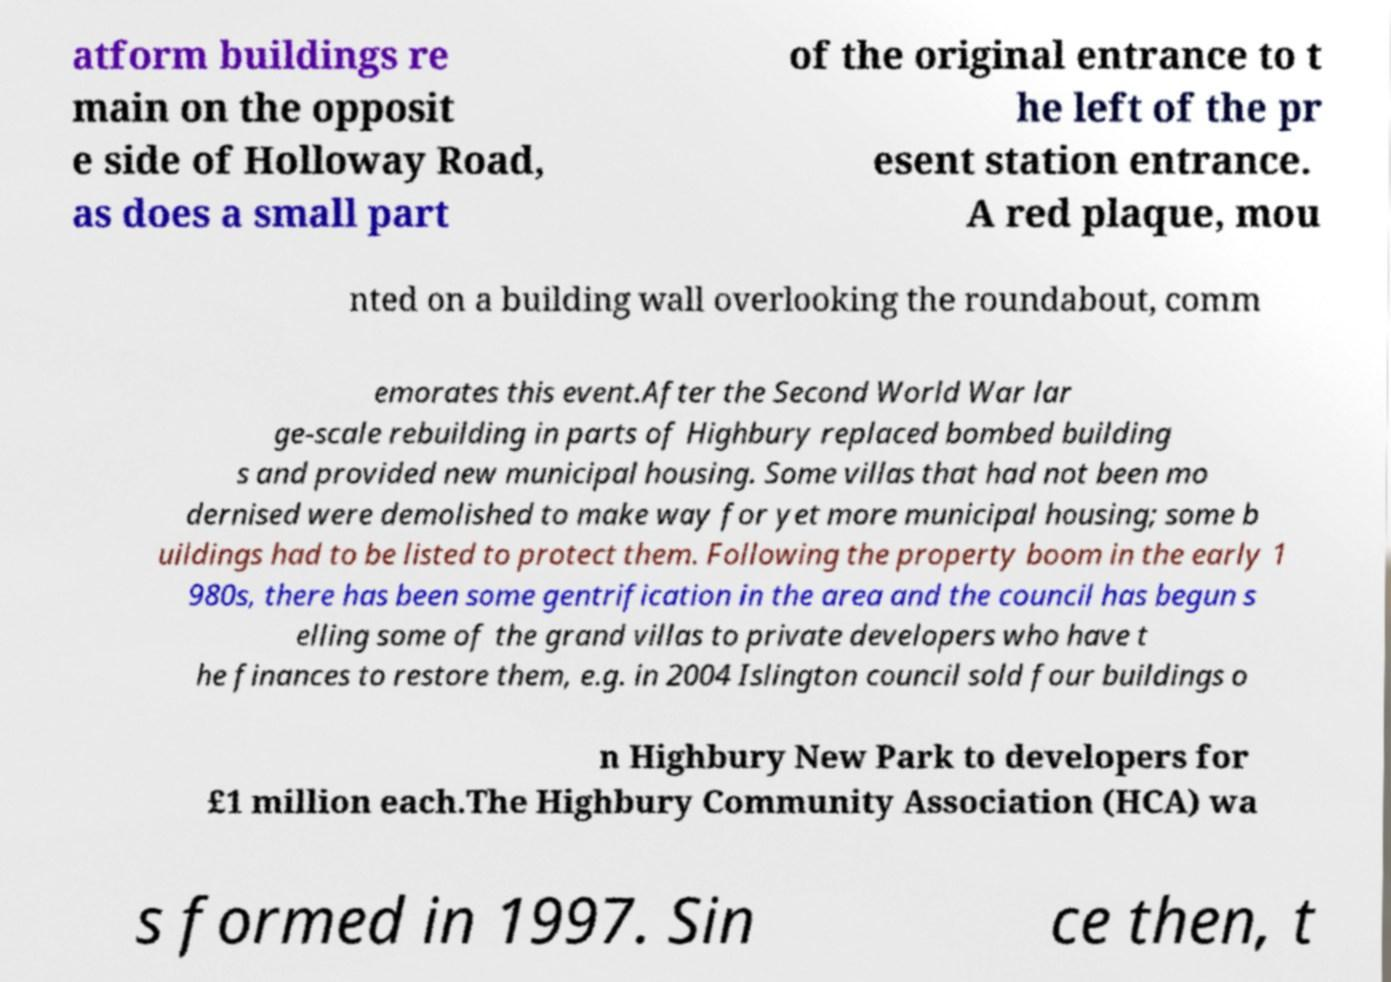Please identify and transcribe the text found in this image. atform buildings re main on the opposit e side of Holloway Road, as does a small part of the original entrance to t he left of the pr esent station entrance. A red plaque, mou nted on a building wall overlooking the roundabout, comm emorates this event.After the Second World War lar ge-scale rebuilding in parts of Highbury replaced bombed building s and provided new municipal housing. Some villas that had not been mo dernised were demolished to make way for yet more municipal housing; some b uildings had to be listed to protect them. Following the property boom in the early 1 980s, there has been some gentrification in the area and the council has begun s elling some of the grand villas to private developers who have t he finances to restore them, e.g. in 2004 Islington council sold four buildings o n Highbury New Park to developers for £1 million each.The Highbury Community Association (HCA) wa s formed in 1997. Sin ce then, t 